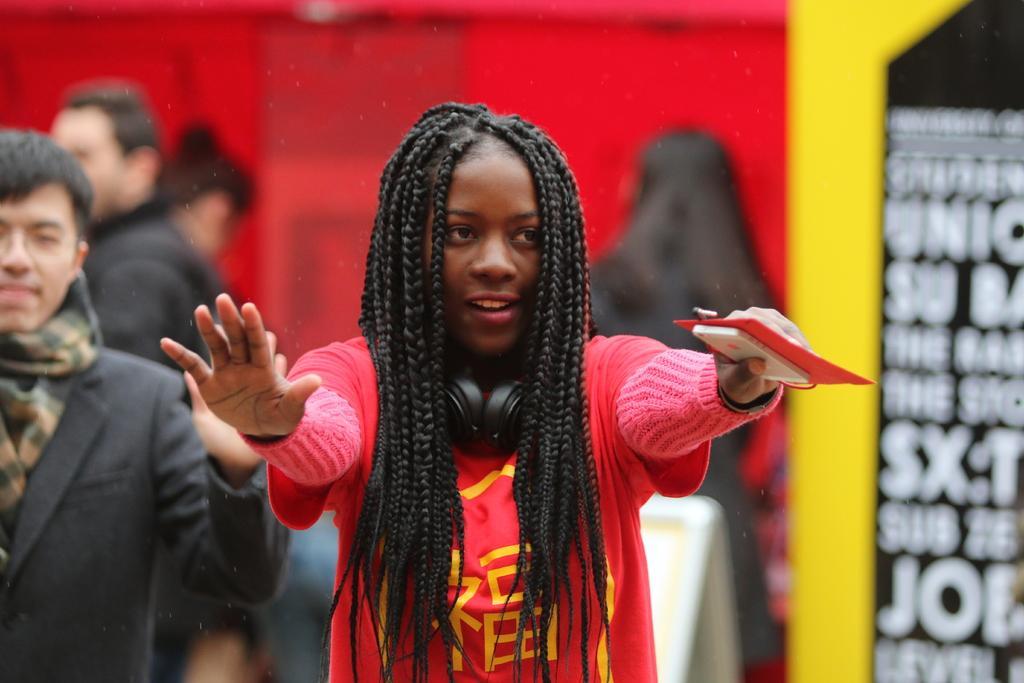In one or two sentences, can you explain what this image depicts? In this image there are a few people standing, one of them is holding a mobile and a paper in her hand, there is an object on the surface. In the background there is a wall and a banner with some text. 